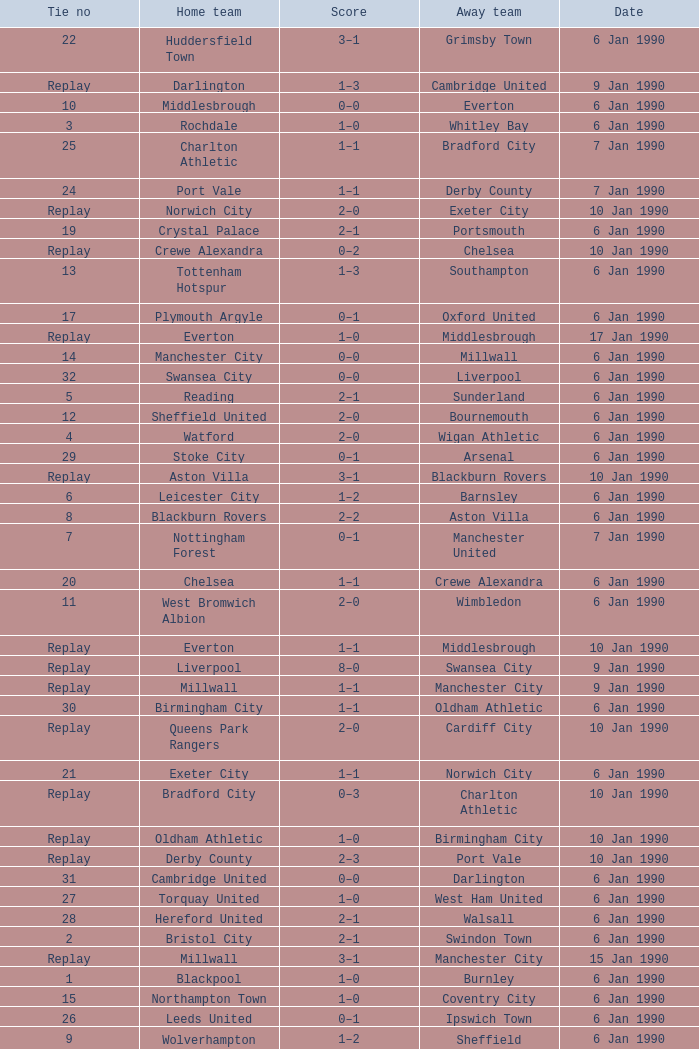Give me the full table as a dictionary. {'header': ['Tie no', 'Home team', 'Score', 'Away team', 'Date'], 'rows': [['22', 'Huddersfield Town', '3–1', 'Grimsby Town', '6 Jan 1990'], ['Replay', 'Darlington', '1–3', 'Cambridge United', '9 Jan 1990'], ['10', 'Middlesbrough', '0–0', 'Everton', '6 Jan 1990'], ['3', 'Rochdale', '1–0', 'Whitley Bay', '6 Jan 1990'], ['25', 'Charlton Athletic', '1–1', 'Bradford City', '7 Jan 1990'], ['24', 'Port Vale', '1–1', 'Derby County', '7 Jan 1990'], ['Replay', 'Norwich City', '2–0', 'Exeter City', '10 Jan 1990'], ['19', 'Crystal Palace', '2–1', 'Portsmouth', '6 Jan 1990'], ['Replay', 'Crewe Alexandra', '0–2', 'Chelsea', '10 Jan 1990'], ['13', 'Tottenham Hotspur', '1–3', 'Southampton', '6 Jan 1990'], ['17', 'Plymouth Argyle', '0–1', 'Oxford United', '6 Jan 1990'], ['Replay', 'Everton', '1–0', 'Middlesbrough', '17 Jan 1990'], ['14', 'Manchester City', '0–0', 'Millwall', '6 Jan 1990'], ['32', 'Swansea City', '0–0', 'Liverpool', '6 Jan 1990'], ['5', 'Reading', '2–1', 'Sunderland', '6 Jan 1990'], ['12', 'Sheffield United', '2–0', 'Bournemouth', '6 Jan 1990'], ['4', 'Watford', '2–0', 'Wigan Athletic', '6 Jan 1990'], ['29', 'Stoke City', '0–1', 'Arsenal', '6 Jan 1990'], ['Replay', 'Aston Villa', '3–1', 'Blackburn Rovers', '10 Jan 1990'], ['6', 'Leicester City', '1–2', 'Barnsley', '6 Jan 1990'], ['8', 'Blackburn Rovers', '2–2', 'Aston Villa', '6 Jan 1990'], ['7', 'Nottingham Forest', '0–1', 'Manchester United', '7 Jan 1990'], ['20', 'Chelsea', '1–1', 'Crewe Alexandra', '6 Jan 1990'], ['11', 'West Bromwich Albion', '2–0', 'Wimbledon', '6 Jan 1990'], ['Replay', 'Everton', '1–1', 'Middlesbrough', '10 Jan 1990'], ['Replay', 'Liverpool', '8–0', 'Swansea City', '9 Jan 1990'], ['Replay', 'Millwall', '1–1', 'Manchester City', '9 Jan 1990'], ['30', 'Birmingham City', '1–1', 'Oldham Athletic', '6 Jan 1990'], ['Replay', 'Queens Park Rangers', '2–0', 'Cardiff City', '10 Jan 1990'], ['21', 'Exeter City', '1–1', 'Norwich City', '6 Jan 1990'], ['Replay', 'Bradford City', '0–3', 'Charlton Athletic', '10 Jan 1990'], ['Replay', 'Oldham Athletic', '1–0', 'Birmingham City', '10 Jan 1990'], ['Replay', 'Derby County', '2–3', 'Port Vale', '10 Jan 1990'], ['31', 'Cambridge United', '0–0', 'Darlington', '6 Jan 1990'], ['27', 'Torquay United', '1–0', 'West Ham United', '6 Jan 1990'], ['28', 'Hereford United', '2–1', 'Walsall', '6 Jan 1990'], ['2', 'Bristol City', '2–1', 'Swindon Town', '6 Jan 1990'], ['Replay', 'Millwall', '3–1', 'Manchester City', '15 Jan 1990'], ['1', 'Blackpool', '1–0', 'Burnley', '6 Jan 1990'], ['15', 'Northampton Town', '1–0', 'Coventry City', '6 Jan 1990'], ['26', 'Leeds United', '0–1', 'Ipswich Town', '6 Jan 1990'], ['9', 'Wolverhampton Wanderers', '1–2', 'Sheffield Wednesday', '6 Jan 1990'], ['23', 'Cardiff City', '0–0', 'Queens Park Rangers', '6 Jan 1990'], ['16', 'Brighton & Hove Albion', '4–1', 'Luton Town', '6 Jan 1990'], ['18', 'Hull City', '0–1', 'Newcastle United', '6 Jan 1990']]} What was the score of the game against away team crewe alexandra? 1–1. 